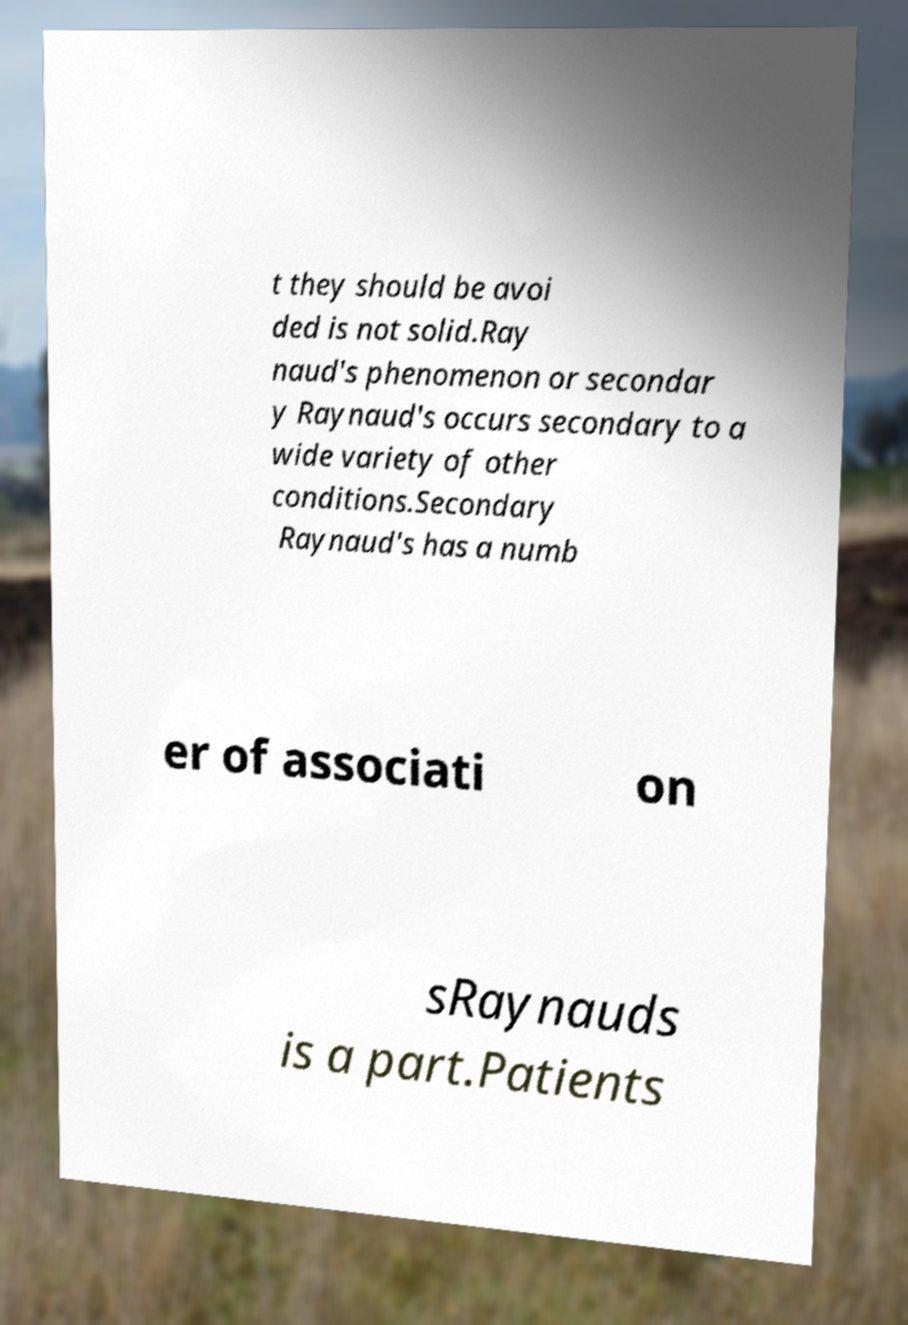There's text embedded in this image that I need extracted. Can you transcribe it verbatim? t they should be avoi ded is not solid.Ray naud's phenomenon or secondar y Raynaud's occurs secondary to a wide variety of other conditions.Secondary Raynaud's has a numb er of associati on sRaynauds is a part.Patients 